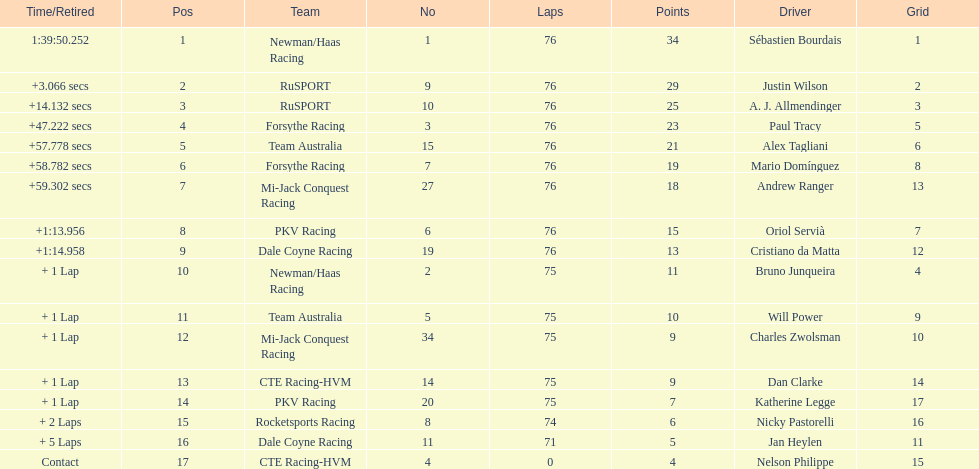What was the total points that canada earned together? 62. 